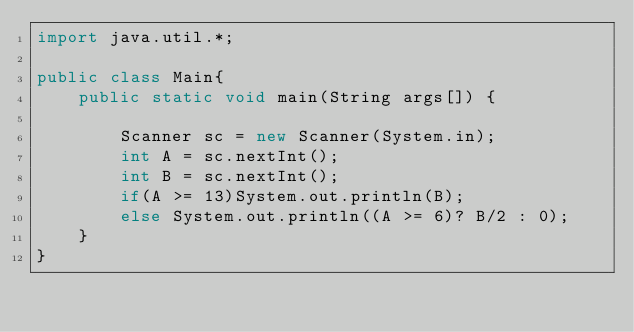<code> <loc_0><loc_0><loc_500><loc_500><_Java_>import java.util.*;

public class Main{
	public static void main(String args[]) {

		Scanner sc = new Scanner(System.in);
		int A = sc.nextInt();
		int B = sc.nextInt();
		if(A >= 13)System.out.println(B);
		else System.out.println((A >= 6)? B/2 : 0);
	}
}</code> 